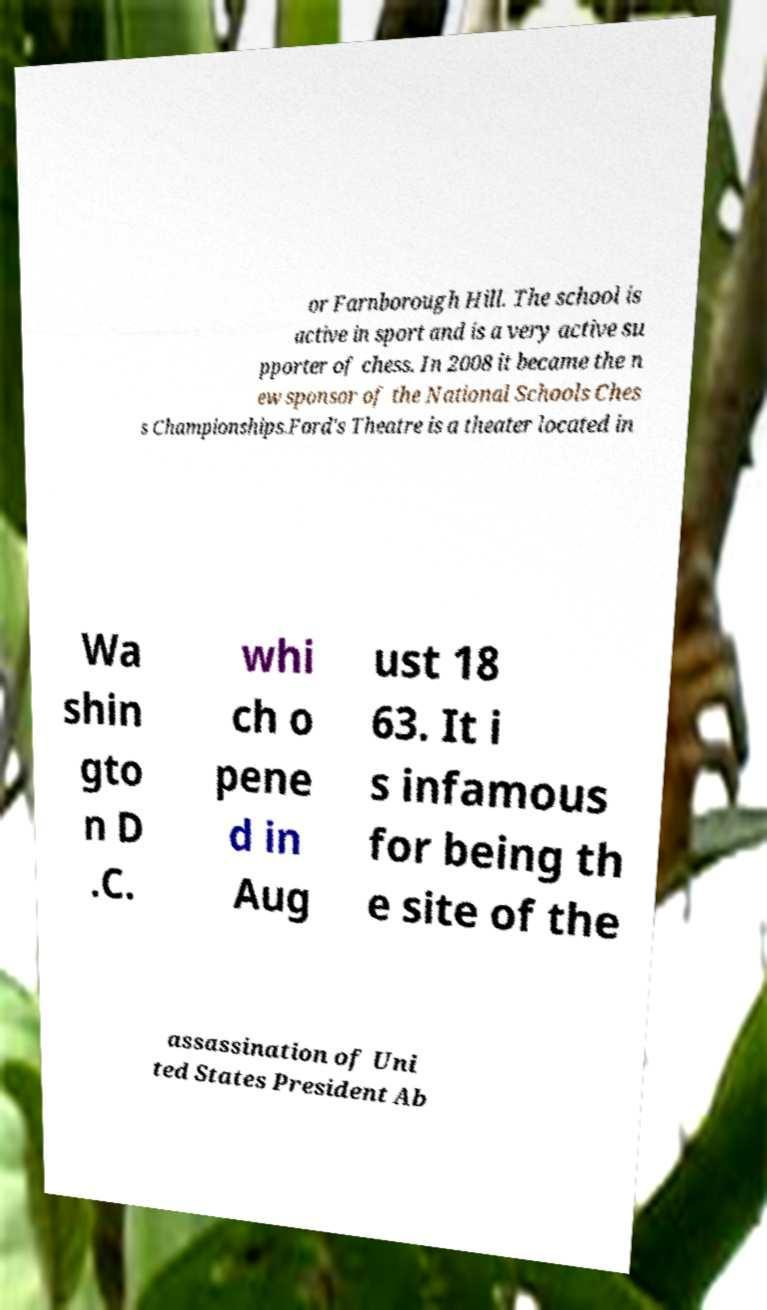Please identify and transcribe the text found in this image. or Farnborough Hill. The school is active in sport and is a very active su pporter of chess. In 2008 it became the n ew sponsor of the National Schools Ches s Championships.Ford's Theatre is a theater located in Wa shin gto n D .C. whi ch o pene d in Aug ust 18 63. It i s infamous for being th e site of the assassination of Uni ted States President Ab 